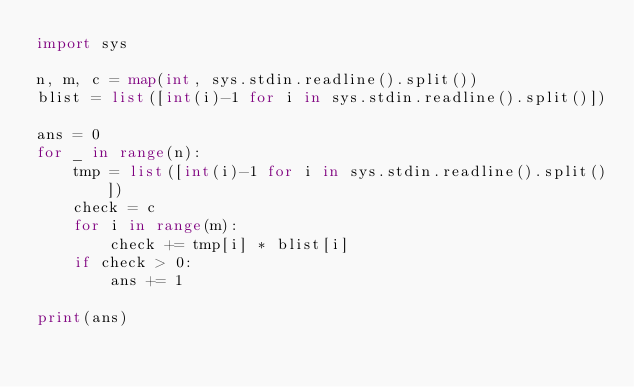Convert code to text. <code><loc_0><loc_0><loc_500><loc_500><_Python_>import sys

n, m, c = map(int, sys.stdin.readline().split())
blist = list([int(i)-1 for i in sys.stdin.readline().split()])

ans = 0
for _ in range(n):
    tmp = list([int(i)-1 for i in sys.stdin.readline().split()])
    check = c
    for i in range(m):
        check += tmp[i] * blist[i]
    if check > 0:
        ans += 1

print(ans)
</code> 